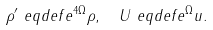Convert formula to latex. <formula><loc_0><loc_0><loc_500><loc_500>\rho ^ { \prime } & \ e q d e f e ^ { 4 \Omega } \rho , \quad U \ e q d e f e ^ { \Omega } u .</formula> 